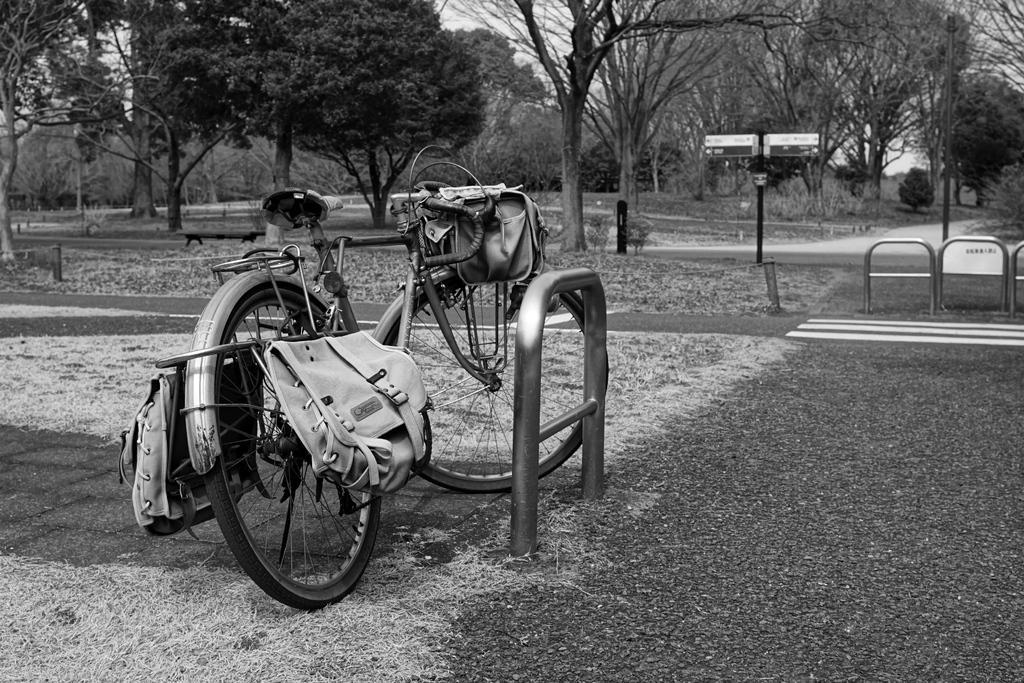How would you summarize this image in a sentence or two? In this picture I can see bicycle on the left side on the road. I can see the metal grill fence. I can see trees in the background. 